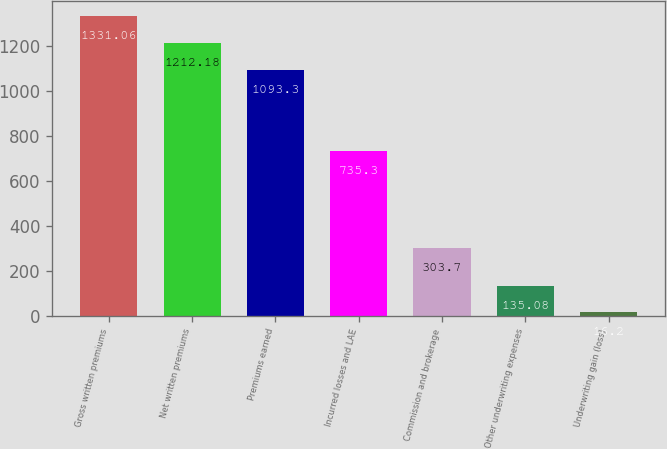<chart> <loc_0><loc_0><loc_500><loc_500><bar_chart><fcel>Gross written premiums<fcel>Net written premiums<fcel>Premiums earned<fcel>Incurred losses and LAE<fcel>Commission and brokerage<fcel>Other underwriting expenses<fcel>Underwriting gain (loss)<nl><fcel>1331.06<fcel>1212.18<fcel>1093.3<fcel>735.3<fcel>303.7<fcel>135.08<fcel>16.2<nl></chart> 